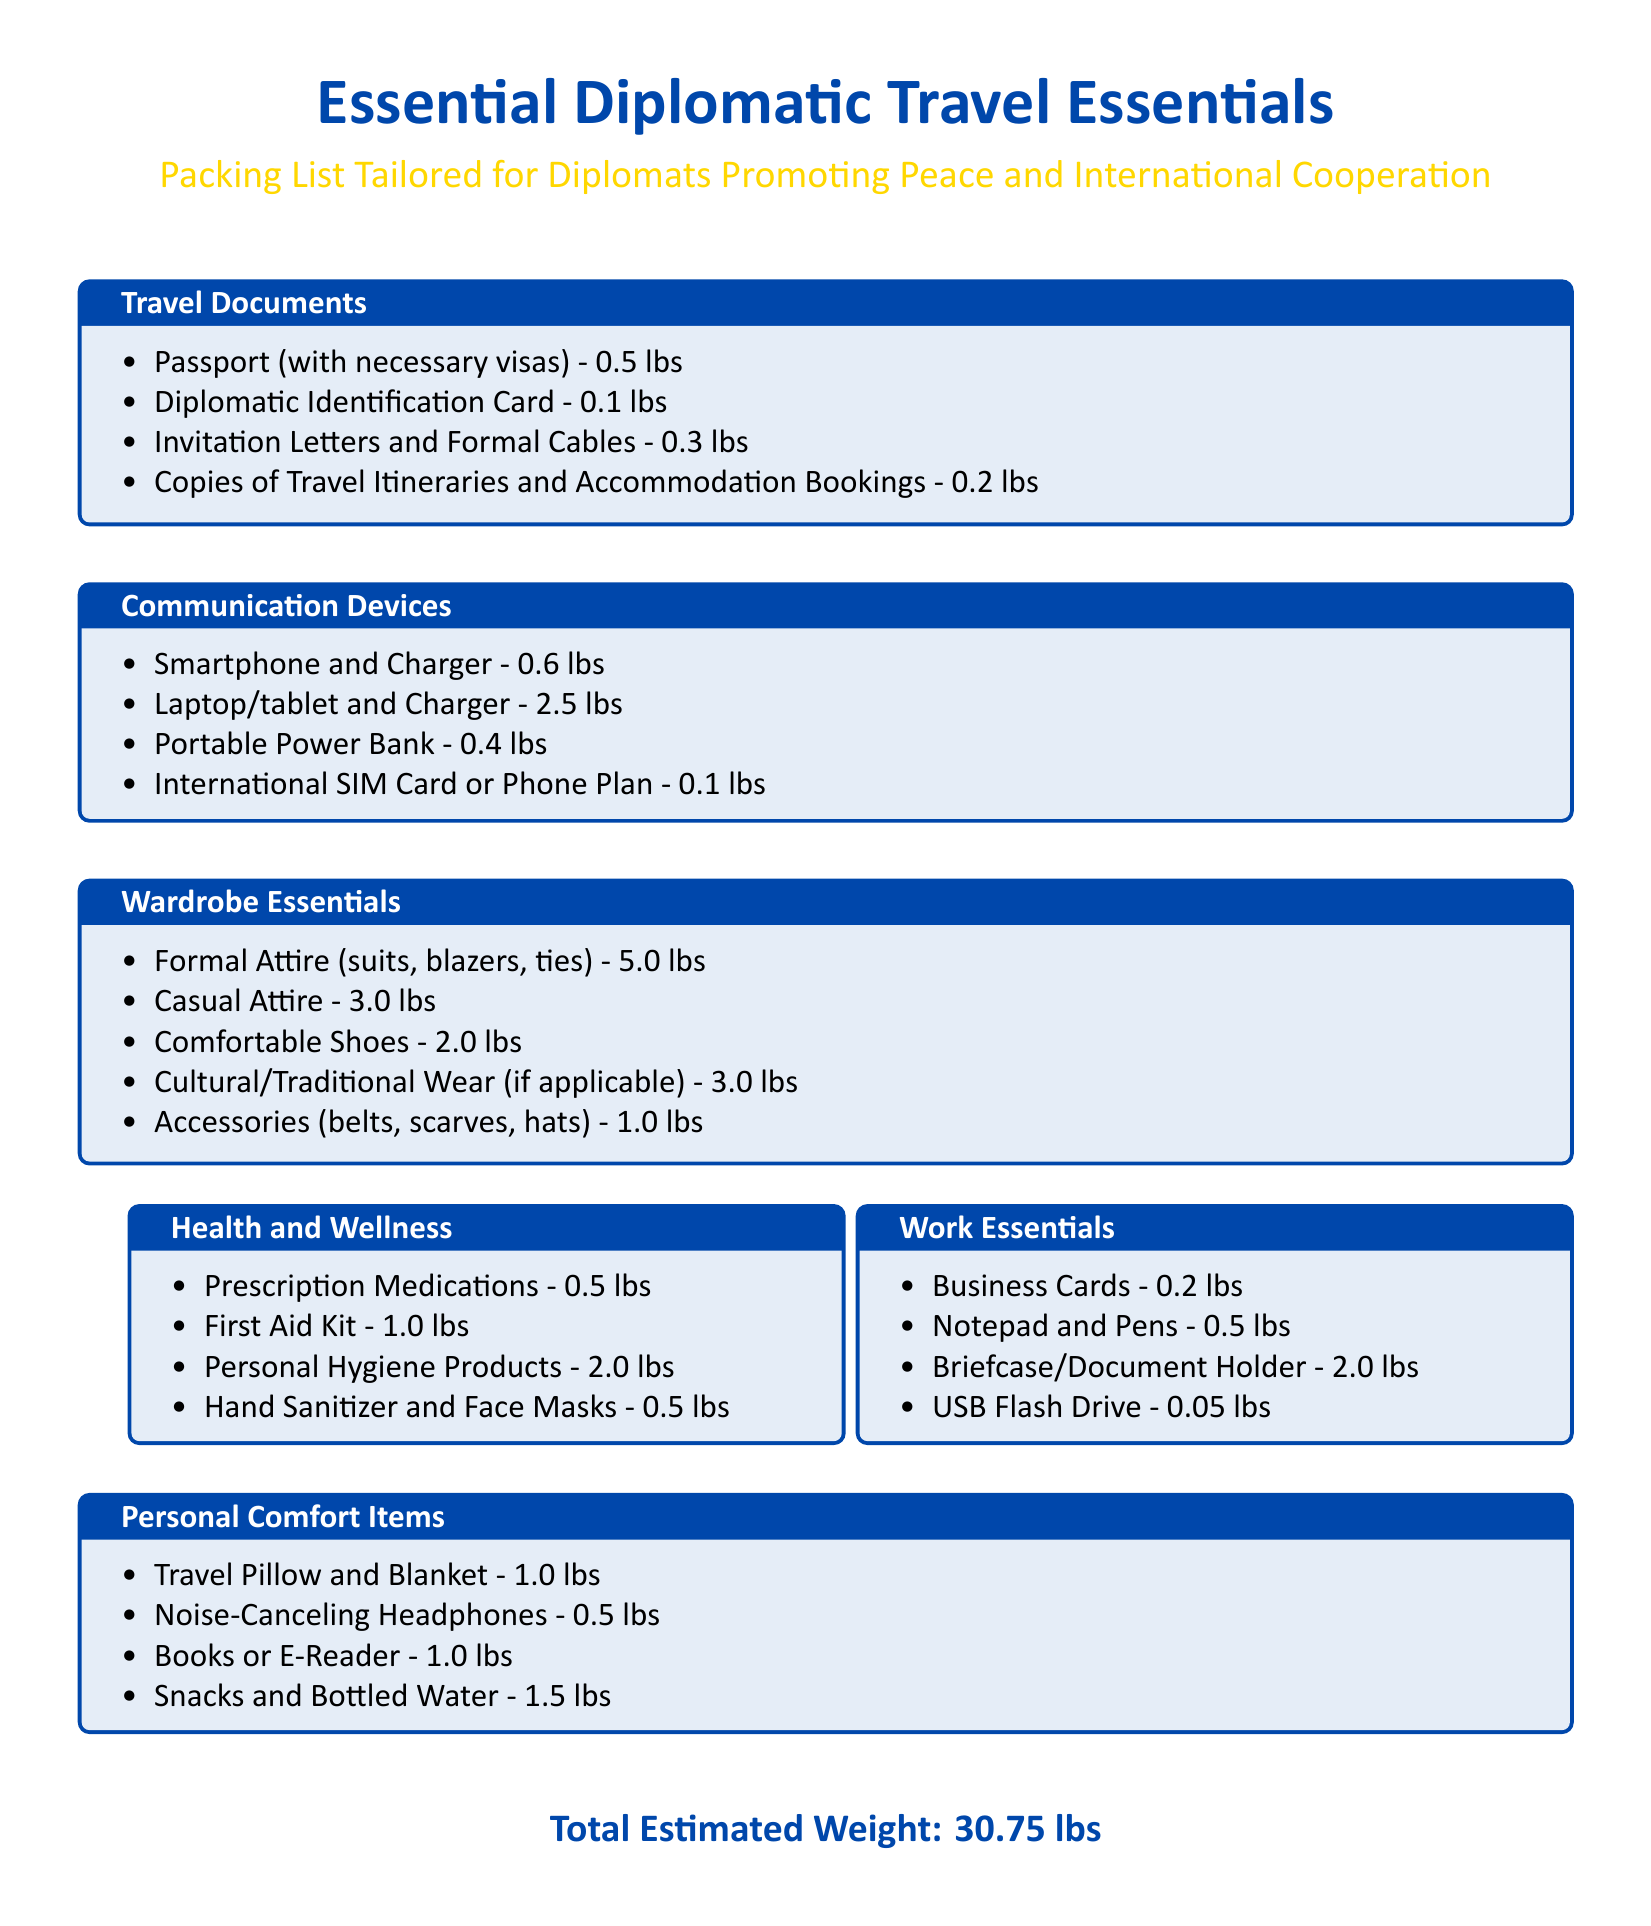What is the total estimated weight of the packing list? The total estimated weight is provided at the end of the document.
Answer: 30.75 lbs How much do formal attire items weigh? The weight of formal attire is listed under wardrobe essentials, which sums the weight of the included items.
Answer: 5.0 lbs What item requires a portable power bank? Communication devices include a portable power bank, which is essential for keeping devices charged.
Answer: Portable Power Bank What is included in the health and wellness category? This category lists various items under health and wellness, detailing what should be included for personal well-being.
Answer: Prescription Medications, First Aid Kit, Personal Hygiene Products, Hand Sanitizer and Face Masks How much does a laptop/tablet and charger weigh? The specific weight of the laptop/tablet and charger is mentioned in the communication devices section.
Answer: 2.5 lbs What type of attire is listed for cultural or traditional wear? This part refers to unique cultural needs, emphasizing the inclusion of attire that represents one's heritage.
Answer: Cultural/Traditional Wear What item can be found under work essentials that is lightest? The document specifies weights of different items in the work essentials section, identifying which is the lightest.
Answer: USB Flash Drive How many items are listed under the communication devices category? The document counts the number of items detailed in the communication devices section to retrieve this information.
Answer: 4 items 